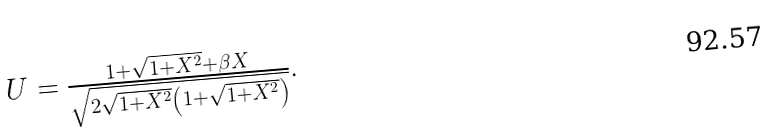Convert formula to latex. <formula><loc_0><loc_0><loc_500><loc_500>\begin{array} { c } U = \frac { 1 + \sqrt { 1 + X ^ { 2 } } + \beta X } { \sqrt { 2 \sqrt { 1 + X ^ { 2 } } \left ( 1 + \sqrt { 1 + X ^ { 2 } } \right ) } } . \end{array}</formula> 